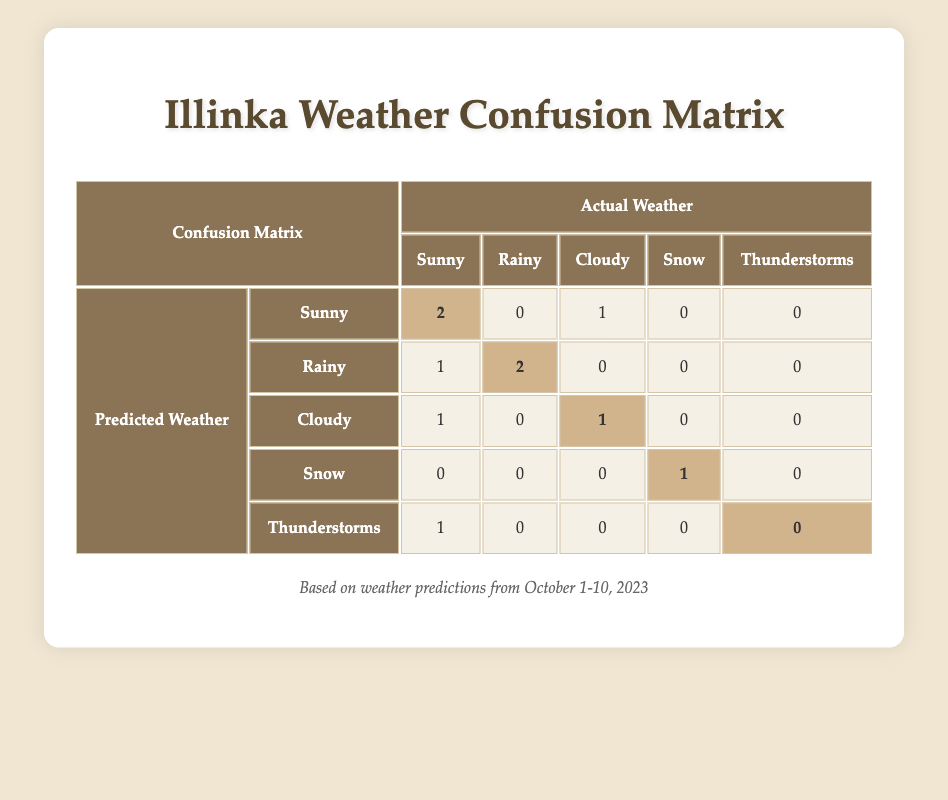What is the total number of correct predictions for Sunny weather? There are 2 correct predictions for Sunny weather, as indicated by the highlighted value in the row for Sunny under the predicted weather and in the column for Sunny under the actual weather.
Answer: 2 How many times was Rainy weather correctly predicted? The highlighted value in the Rainy row under predicted weather and the Rainy column under actual weather shows that there were 2 correct predictions for Rainy weather.
Answer: 2 What is the predicted condition on October 3? Looking at the table, the date October 3 corresponds to the row where the predicted condition is Cloudy, which is directly noted in the table.
Answer: Cloudy Was there ever a prediction for Thunderstorms that was actually Sunny? In the table, there is a prediction of Thunderstorms on October 8, and the actual condition was Sunny, which matches the question's criteria.
Answer: Yes How many predictions were incorrect for Cloudy weather? The row for Cloudy under predicted weather shows one incorrect prediction, which is the count of cases where the actual weather was not Cloudy. Specifically, there was 1 prediction of Cloudy that was actually Sunny.
Answer: 1 What percentage of times did the weather predictions match the actual weather conditions? First, we count the total predictions: 10. The correct predictions are 5 (2 Sunny, 2 Rainy, 1 Cloudy). To find the percentage, we divide 5 by 10 and multiply by 100, which gives us 50%.
Answer: 50% Which weather condition had the most incorrect predictions? By examining the rows, Cloudy had 2 incorrect predictions (1 for Sunny, and 1 for Rainy), while other conditions also had incorrect predictions but not exceeding that number. Thus, Cloudy has the highest incorrect predictions.
Answer: Cloudy How many total predictions were made for each weather condition? Summing up the predictions from all rows: Sunny (3), Rainy (3), Cloudy (2), Snow (1), and Thunderstorms (1). Thus, for Sunny and Rainy, there were 3 predictions for each.
Answer: Sunny: 3, Rainy: 3, Cloudy: 2, Snow: 1, Thunderstorms: 1 What is the total number of Snow predictions that were also correct? The Snow row in the table shows 1 correct prediction, as indicated by the highlighted value. Therefore, the total number of correct predictions for Snow is 1.
Answer: 1 